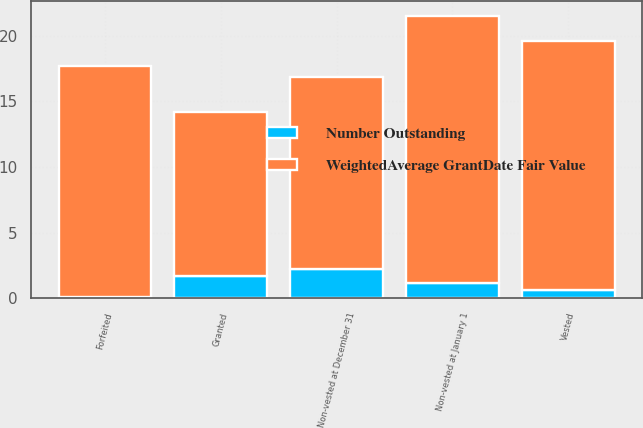Convert chart to OTSL. <chart><loc_0><loc_0><loc_500><loc_500><stacked_bar_chart><ecel><fcel>Non-vested at January 1<fcel>Granted<fcel>Vested<fcel>Forfeited<fcel>Non-vested at December 31<nl><fcel>Number Outstanding<fcel>1.2<fcel>1.7<fcel>0.6<fcel>0.1<fcel>2.2<nl><fcel>WeightedAverage GrantDate Fair Value<fcel>20.32<fcel>12.46<fcel>18.96<fcel>17.55<fcel>14.63<nl></chart> 